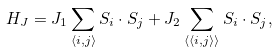Convert formula to latex. <formula><loc_0><loc_0><loc_500><loc_500>H _ { J } = J _ { 1 } \sum _ { \langle i , j \rangle } { S } _ { i } \cdot { S } _ { j } + J _ { 2 } \sum _ { \langle \langle i , j \rangle \rangle } { S } _ { i } \cdot { S } _ { j } ,</formula> 